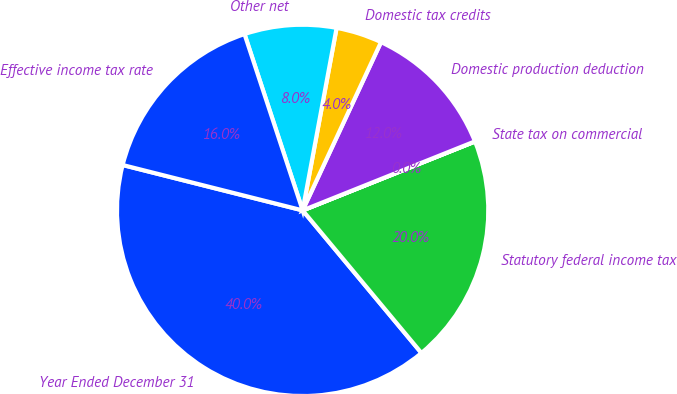<chart> <loc_0><loc_0><loc_500><loc_500><pie_chart><fcel>Year Ended December 31<fcel>Statutory federal income tax<fcel>State tax on commercial<fcel>Domestic production deduction<fcel>Domestic tax credits<fcel>Other net<fcel>Effective income tax rate<nl><fcel>39.99%<fcel>20.0%<fcel>0.01%<fcel>12.0%<fcel>4.01%<fcel>8.0%<fcel>16.0%<nl></chart> 